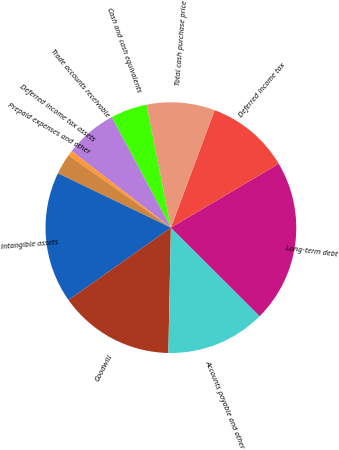<chart> <loc_0><loc_0><loc_500><loc_500><pie_chart><fcel>Cash and cash equivalents<fcel>Trade accounts receivable<fcel>Deferred income tax assets<fcel>Prepaid expenses and other<fcel>Intangible assets<fcel>Goodwill<fcel>Accounts payable and other<fcel>Long-term debt<fcel>Deferred income tax<fcel>Total cash purchase price<nl><fcel>4.71%<fcel>6.74%<fcel>0.64%<fcel>2.67%<fcel>16.92%<fcel>14.89%<fcel>12.85%<fcel>20.99%<fcel>10.81%<fcel>8.78%<nl></chart> 